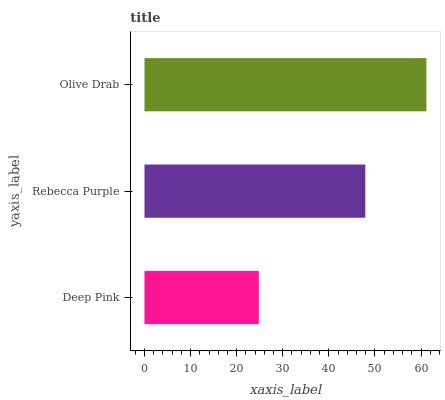Is Deep Pink the minimum?
Answer yes or no. Yes. Is Olive Drab the maximum?
Answer yes or no. Yes. Is Rebecca Purple the minimum?
Answer yes or no. No. Is Rebecca Purple the maximum?
Answer yes or no. No. Is Rebecca Purple greater than Deep Pink?
Answer yes or no. Yes. Is Deep Pink less than Rebecca Purple?
Answer yes or no. Yes. Is Deep Pink greater than Rebecca Purple?
Answer yes or no. No. Is Rebecca Purple less than Deep Pink?
Answer yes or no. No. Is Rebecca Purple the high median?
Answer yes or no. Yes. Is Rebecca Purple the low median?
Answer yes or no. Yes. Is Deep Pink the high median?
Answer yes or no. No. Is Deep Pink the low median?
Answer yes or no. No. 